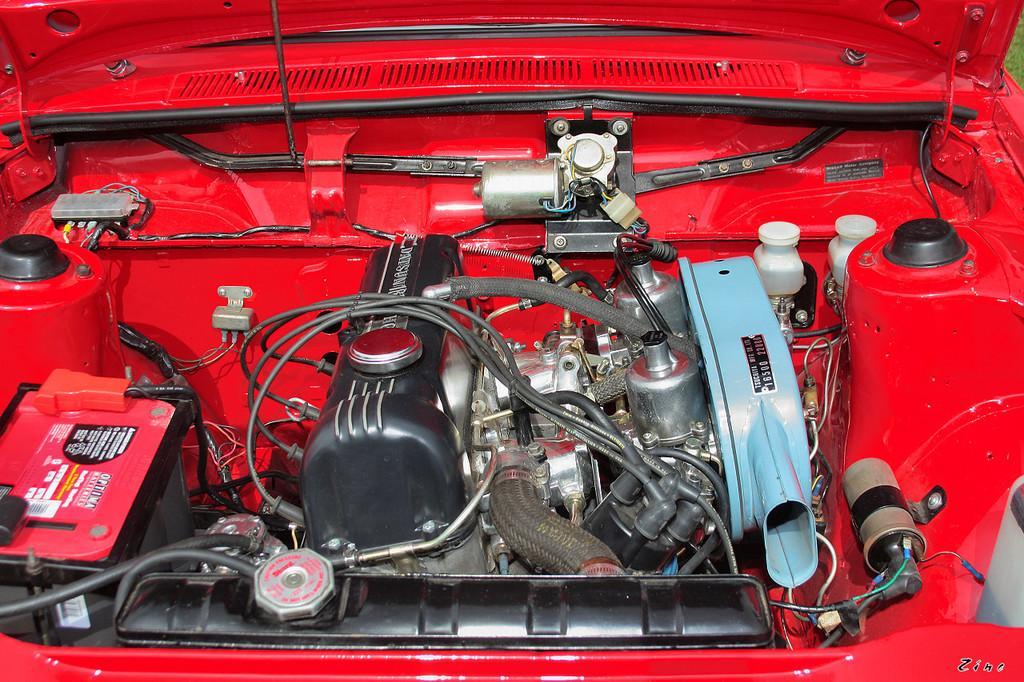Can you describe this image briefly? In the picture there is engine and other parts of a vehicle. 